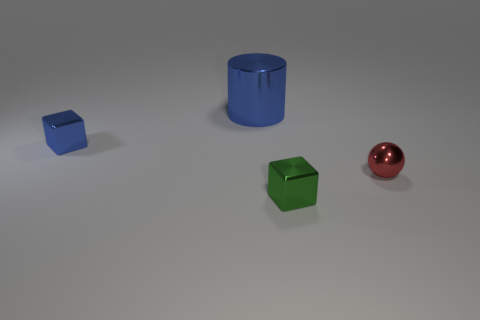Add 3 green blocks. How many objects exist? 7 Subtract all cylinders. How many objects are left? 3 Subtract all things. Subtract all large brown objects. How many objects are left? 0 Add 4 small blue objects. How many small blue objects are left? 5 Add 1 large gray spheres. How many large gray spheres exist? 1 Subtract 0 cyan cubes. How many objects are left? 4 Subtract all purple cubes. Subtract all red spheres. How many cubes are left? 2 Subtract all yellow cylinders. How many gray cubes are left? 0 